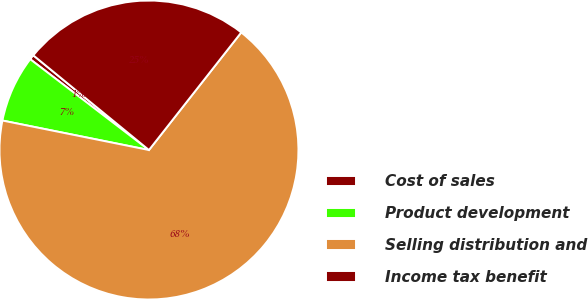Convert chart to OTSL. <chart><loc_0><loc_0><loc_500><loc_500><pie_chart><fcel>Cost of sales<fcel>Product development<fcel>Selling distribution and<fcel>Income tax benefit<nl><fcel>0.53%<fcel>7.23%<fcel>67.57%<fcel>24.67%<nl></chart> 